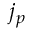Convert formula to latex. <formula><loc_0><loc_0><loc_500><loc_500>j _ { p }</formula> 